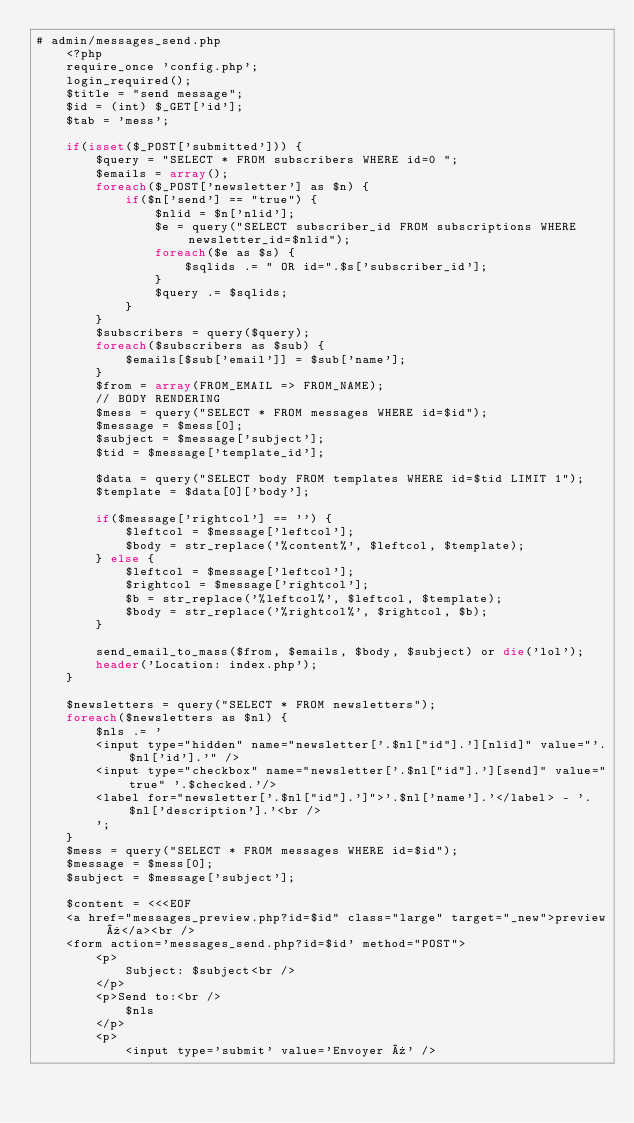<code> <loc_0><loc_0><loc_500><loc_500><_PHP_># admin/messages_send.php 
    <?php 
    require_once 'config.php'; 
    login_required(); 
    $title = "send message"; 
    $id = (int) $_GET['id']; 
    $tab = 'mess'; 
  
    if(isset($_POST['submitted'])) {  
        $query = "SELECT * FROM subscribers WHERE id=0 "; 
        $emails = array(); 
        foreach($_POST['newsletter'] as $n) { 
            if($n['send'] == "true") { 
                $nlid = $n['nlid']; 
                $e = query("SELECT subscriber_id FROM subscriptions WHERE newsletter_id=$nlid"); 
                foreach($e as $s) { 
                    $sqlids .= " OR id=".$s['subscriber_id']; 
                } 
                $query .= $sqlids; 
            } 
        } 
        $subscribers = query($query); 
        foreach($subscribers as $sub) { 
            $emails[$sub['email']] = $sub['name']; 
        } 
        $from = array(FROM_EMAIL => FROM_NAME); 
        // BODY RENDERING 
        $mess = query("SELECT * FROM messages WHERE id=$id"); 
        $message = $mess[0]; 
        $subject = $message['subject']; 
        $tid = $message['template_id']; 
  
        $data = query("SELECT body FROM templates WHERE id=$tid LIMIT 1"); 
        $template = $data[0]['body']; 
  
        if($message['rightcol'] == '') { 
            $leftcol = $message['leftcol']; 
            $body = str_replace('%content%', $leftcol, $template); 
        } else { 
            $leftcol = $message['leftcol']; 
            $rightcol = $message['rightcol']; 
            $b = str_replace('%leftcol%', $leftcol, $template); 
            $body = str_replace('%rightcol%', $rightcol, $b); 
        } 
  
        send_email_to_mass($from, $emails, $body, $subject) or die('lol'); 
        header('Location: index.php'); 
    } 
  
    $newsletters = query("SELECT * FROM newsletters"); 
    foreach($newsletters as $nl) { 
        $nls .= ' 
        <input type="hidden" name="newsletter['.$nl["id"].'][nlid]" value="'.$nl['id'].'" /> 
        <input type="checkbox" name="newsletter['.$nl["id"].'][send]" value="true" '.$checked.'/> 
        <label for="newsletter['.$nl["id"].']">'.$nl['name'].'</label> - '.$nl['description'].'<br /> 
        '; 
    } 
    $mess = query("SELECT * FROM messages WHERE id=$id"); 
    $message = $mess[0]; 
    $subject = $message['subject']; 
  
    $content = <<<EOF 
    <a href="messages_preview.php?id=$id" class="large" target="_new">preview »</a><br /> 
    <form action='messages_send.php?id=$id' method="POST"> 
        <p> 
            Subject: $subject<br /> 
        </p> 
        <p>Send to:<br /> 
            $nls
        </p> 
        <p> 
            <input type='submit' value='Envoyer »' /> </code> 